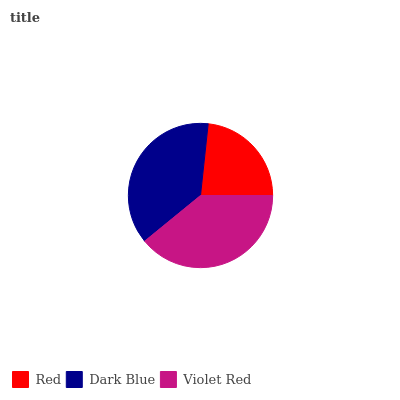Is Red the minimum?
Answer yes or no. Yes. Is Violet Red the maximum?
Answer yes or no. Yes. Is Dark Blue the minimum?
Answer yes or no. No. Is Dark Blue the maximum?
Answer yes or no. No. Is Dark Blue greater than Red?
Answer yes or no. Yes. Is Red less than Dark Blue?
Answer yes or no. Yes. Is Red greater than Dark Blue?
Answer yes or no. No. Is Dark Blue less than Red?
Answer yes or no. No. Is Dark Blue the high median?
Answer yes or no. Yes. Is Dark Blue the low median?
Answer yes or no. Yes. Is Violet Red the high median?
Answer yes or no. No. Is Violet Red the low median?
Answer yes or no. No. 